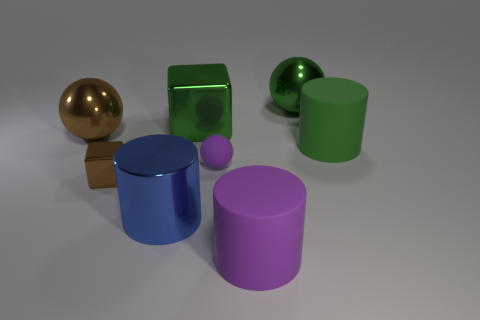Subtract all big spheres. How many spheres are left? 1 Subtract all green cubes. How many cubes are left? 1 Add 1 metallic spheres. How many objects exist? 9 Subtract all blocks. How many objects are left? 6 Subtract 1 cylinders. How many cylinders are left? 2 Subtract all large cyan cubes. Subtract all big balls. How many objects are left? 6 Add 1 tiny blocks. How many tiny blocks are left? 2 Add 3 small purple things. How many small purple things exist? 4 Subtract 1 brown spheres. How many objects are left? 7 Subtract all green spheres. Subtract all brown cylinders. How many spheres are left? 2 